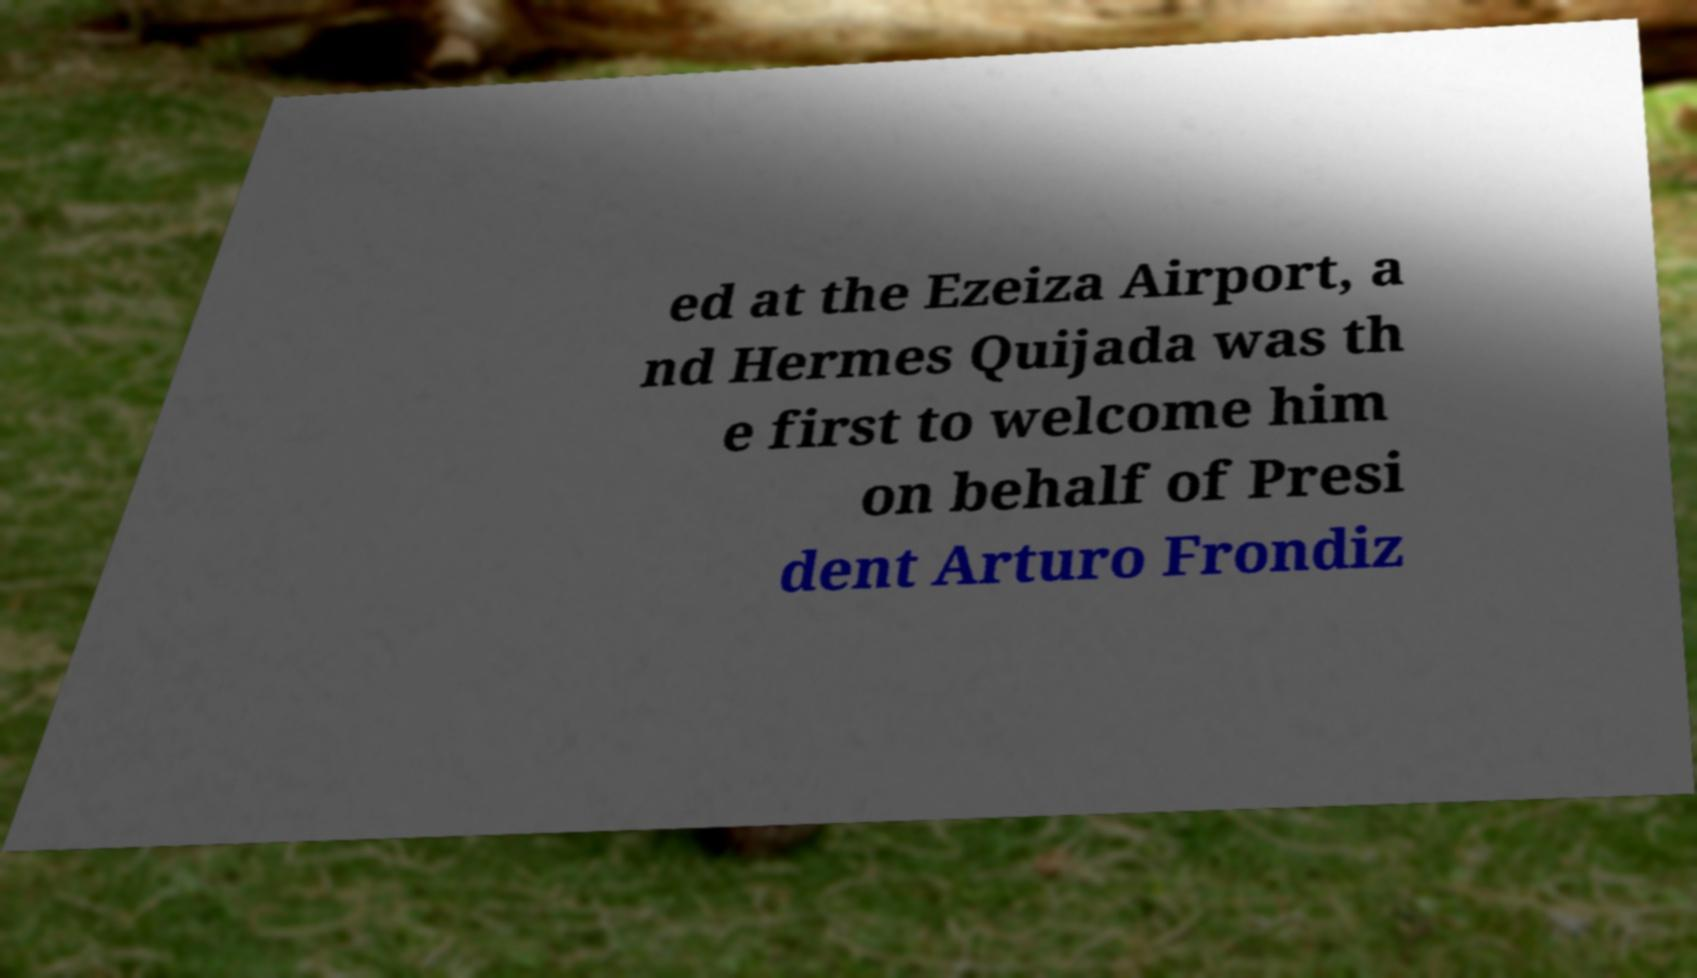Could you extract and type out the text from this image? ed at the Ezeiza Airport, a nd Hermes Quijada was th e first to welcome him on behalf of Presi dent Arturo Frondiz 